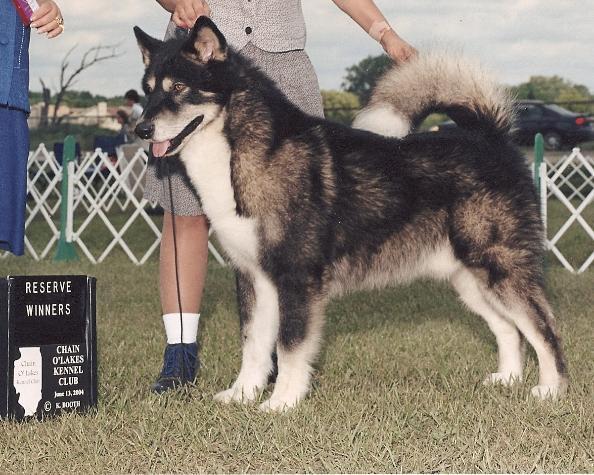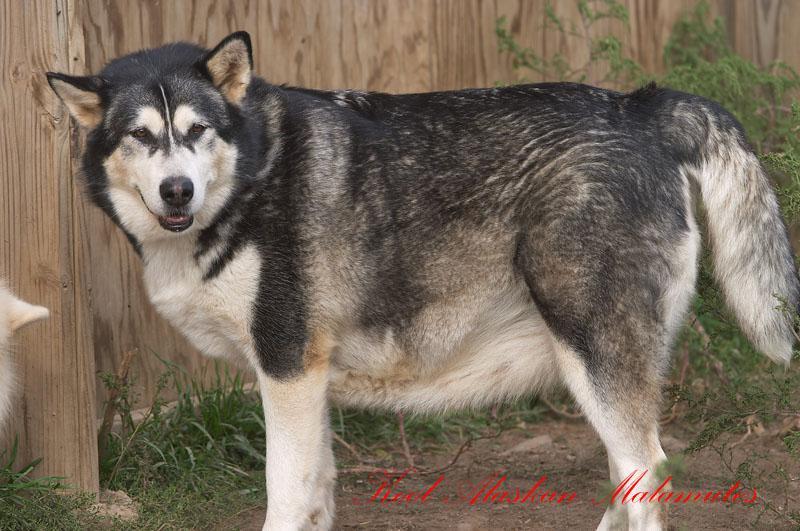The first image is the image on the left, the second image is the image on the right. Given the left and right images, does the statement "Every photo shows exactly one dog, facing left, photographed outside, and not being accompanied by a human." hold true? Answer yes or no. No. The first image is the image on the left, the second image is the image on the right. Evaluate the accuracy of this statement regarding the images: "One image shows a dog standing still in profile facing leftward, with its tail upcurled, and the other image shows a dog with its body turned leftward but its head turned forward and its tail hanging down.". Is it true? Answer yes or no. Yes. 